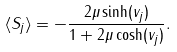Convert formula to latex. <formula><loc_0><loc_0><loc_500><loc_500>\langle S _ { j } \rangle = - \frac { 2 \mu \sinh ( v _ { j } ) } { 1 + 2 \mu \cosh ( v _ { j } ) } .</formula> 